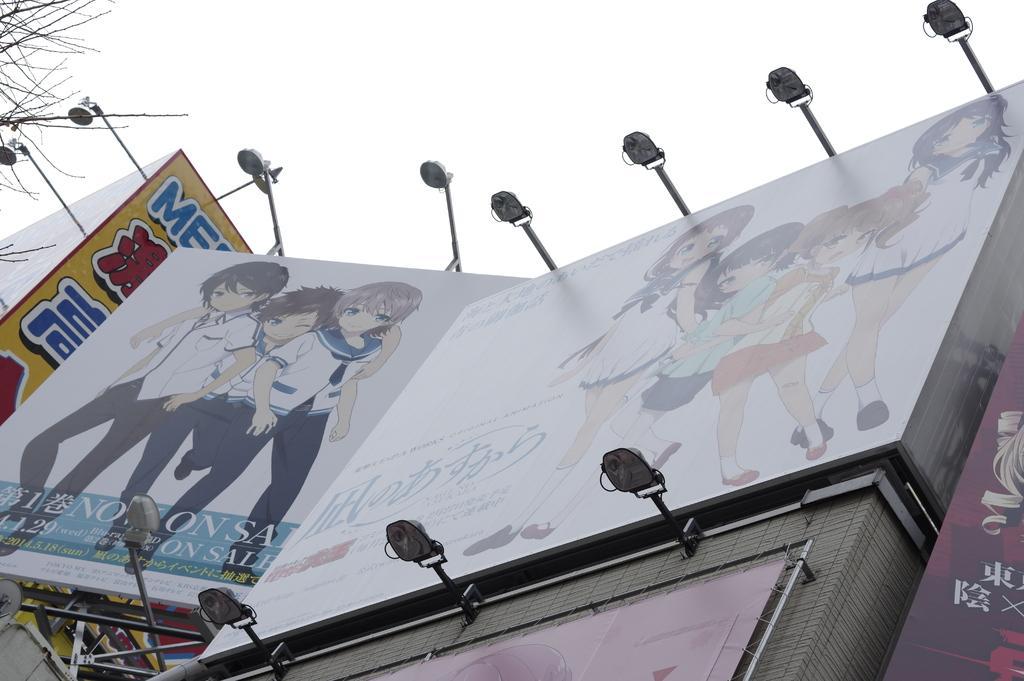How would you summarize this image in a sentence or two? In this image we can see hoardings and lights. In the background there is a sky. 